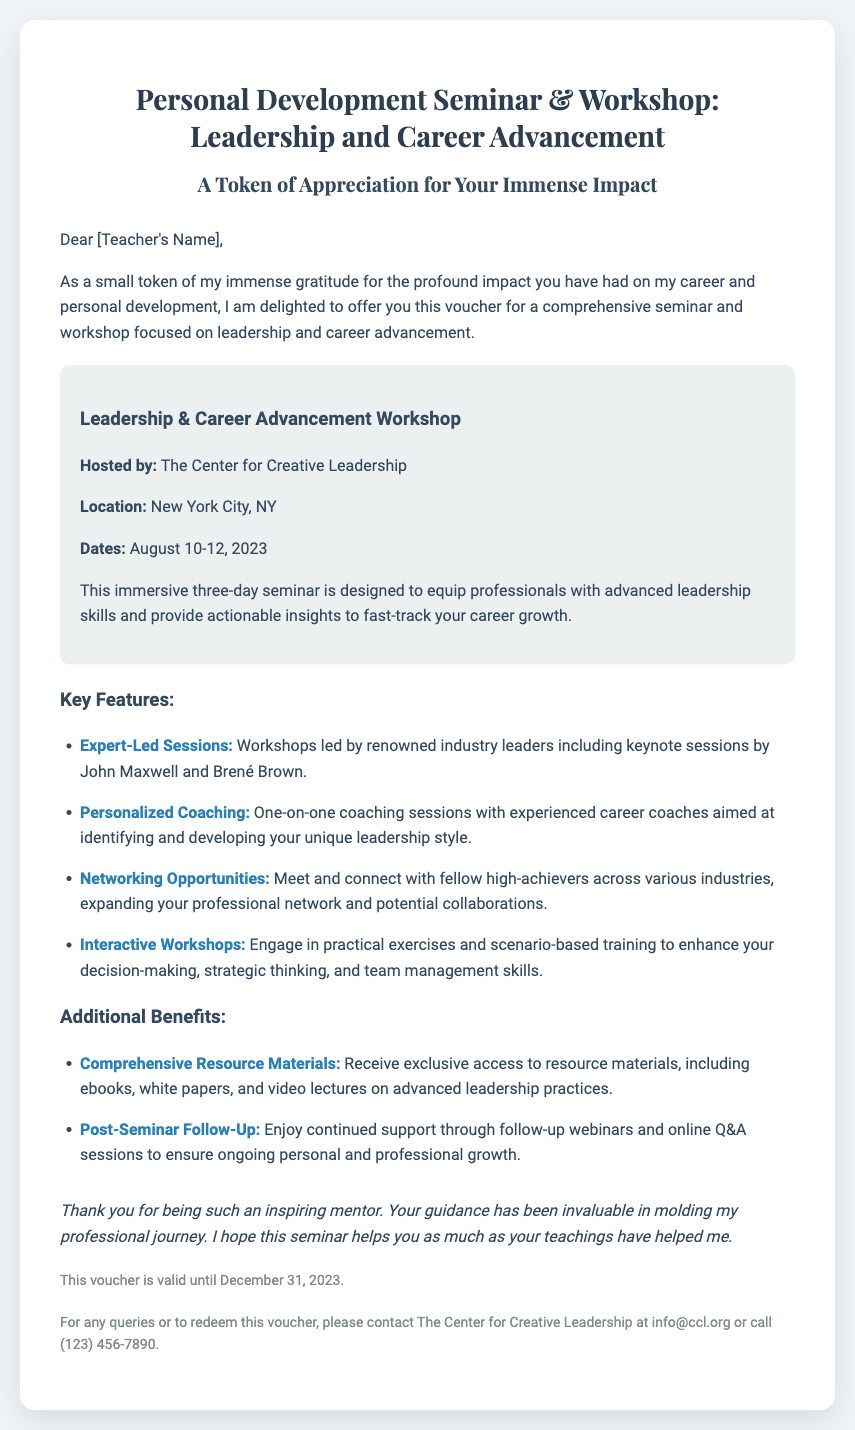What is the title of the seminar? The title is mentioned prominently in the document, highlighting the focus on professional growth.
Answer: Personal Development Seminar & Workshop: Leadership and Career Advancement Who is hosting the seminar? The document states the name of the organization hosting the event.
Answer: The Center for Creative Leadership When will the seminar take place? The specific dates for the seminar are provided in the document.
Answer: August 10-12, 2023 What city is the seminar located in? The document specifies the location where the seminar will be held.
Answer: New York City, NY What is one of the key features mentioned in the seminar? The document lists several features of the seminar, with a focus on expert-led sessions.
Answer: Expert-Led Sessions What type of support is offered after the seminar? The document describes a support mechanism that continues even after the seminar ends.
Answer: Post-Seminar Follow-Up What is the validity period of the voucher? The document includes specific information about when the voucher can be redeemed.
Answer: December 31, 2023 What should one do to redeem the voucher? The document includes contact information for redeeming the voucher.
Answer: Contact The Center for Creative Leadership at info@ccl.org or call (123) 456-7890 